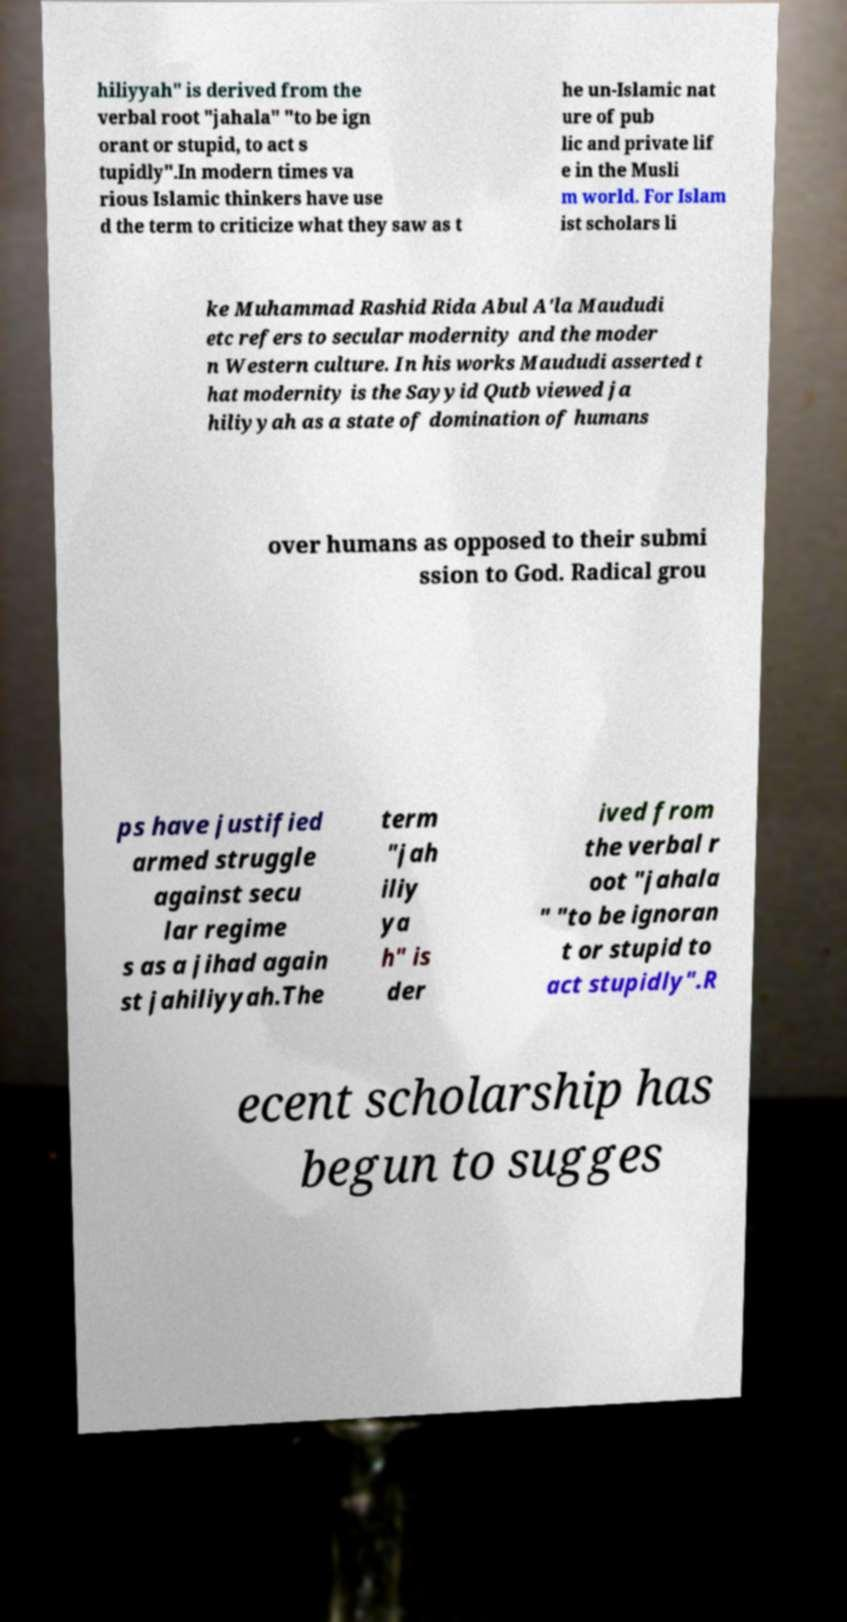Please read and relay the text visible in this image. What does it say? hiliyyah" is derived from the verbal root "jahala" "to be ign orant or stupid, to act s tupidly".In modern times va rious Islamic thinkers have use d the term to criticize what they saw as t he un-Islamic nat ure of pub lic and private lif e in the Musli m world. For Islam ist scholars li ke Muhammad Rashid Rida Abul A'la Maududi etc refers to secular modernity and the moder n Western culture. In his works Maududi asserted t hat modernity is the Sayyid Qutb viewed ja hiliyyah as a state of domination of humans over humans as opposed to their submi ssion to God. Radical grou ps have justified armed struggle against secu lar regime s as a jihad again st jahiliyyah.The term "jah iliy ya h" is der ived from the verbal r oot "jahala " "to be ignoran t or stupid to act stupidly".R ecent scholarship has begun to sugges 